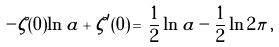<formula> <loc_0><loc_0><loc_500><loc_500>- \zeta ( 0 ) \ln a + \zeta ^ { \prime } ( 0 ) \, = \, \frac { 1 } { 2 } \ln a - \frac { 1 } { 2 } \ln 2 \pi \, ,</formula> 